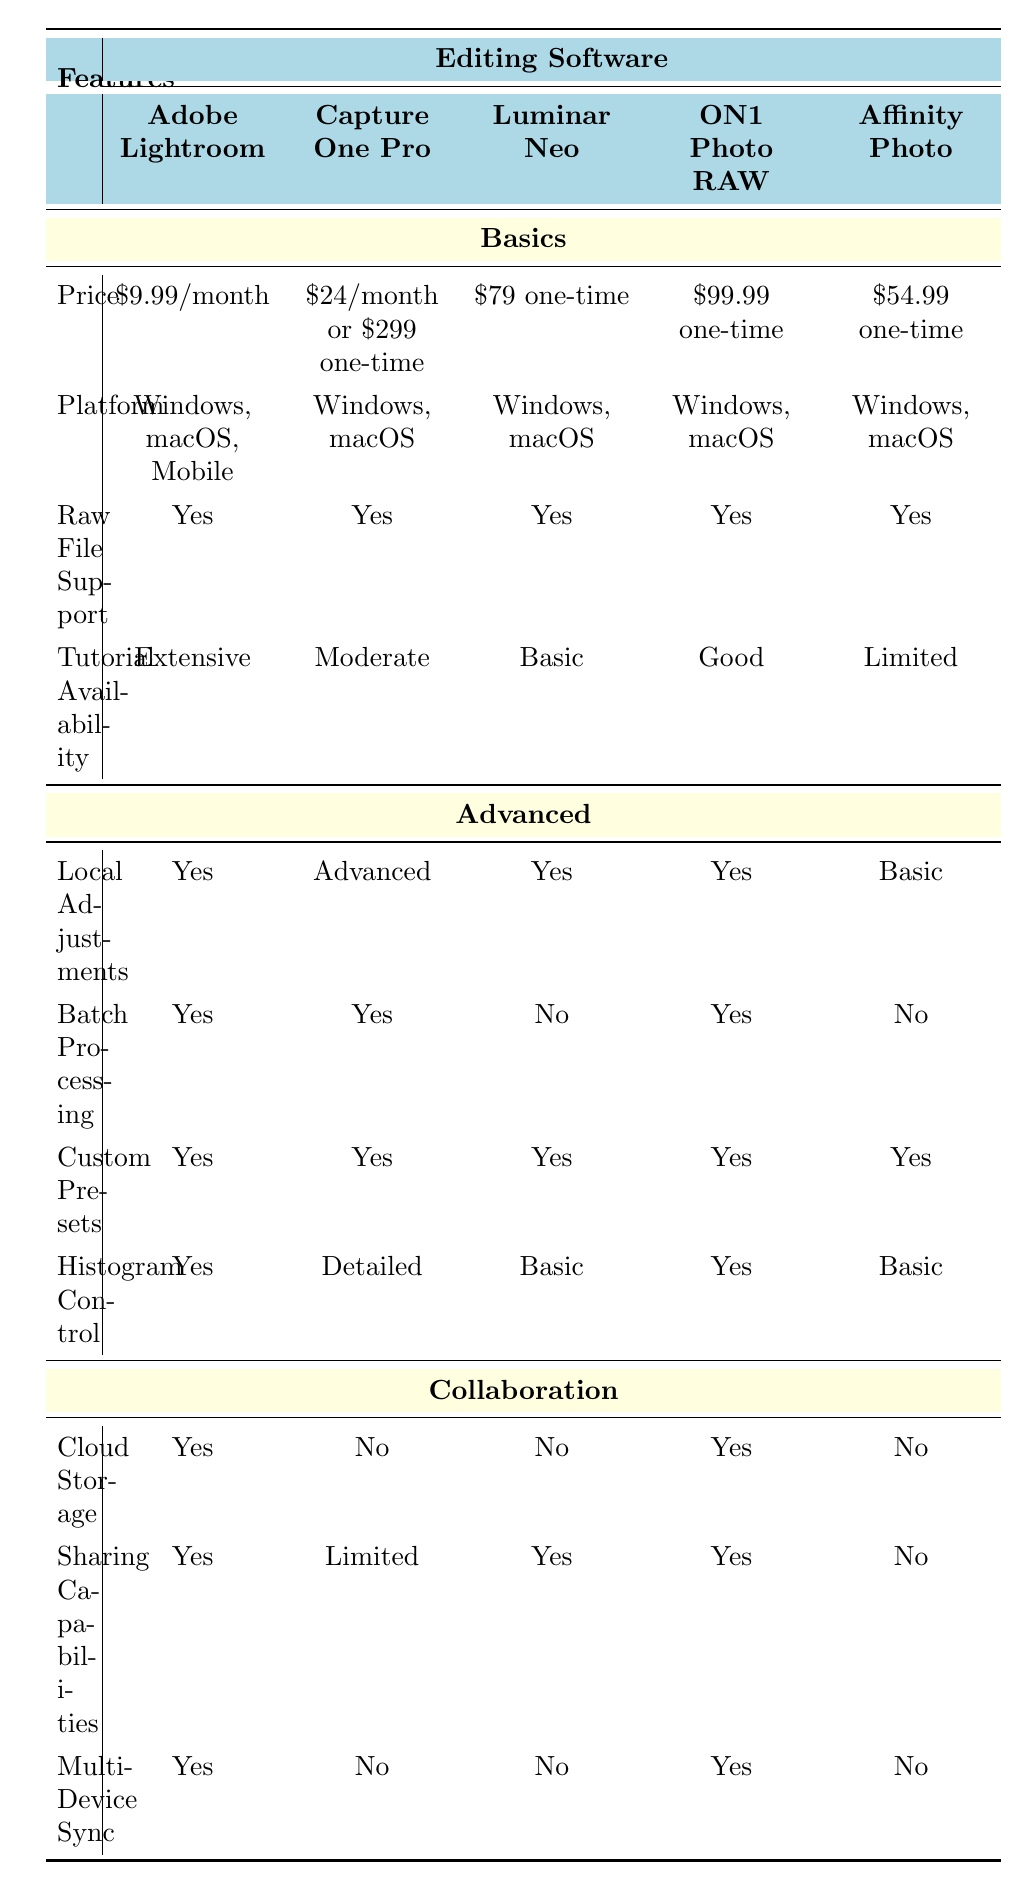What is the price of Adobe Lightroom? The table lists the price of Adobe Lightroom under the "Basics" section. It shows that the price is $9.99 per month.
Answer: $9.99/month Which software offers advanced local adjustments? The table indicates that both Capture One Pro and ON1 Photo RAW offer advanced local adjustments under the "Advanced" section.
Answer: Capture One Pro, ON1 Photo RAW Does Luminar Neo support batch processing? Under the "Advanced" section, the table clearly states that Luminar Neo does not support batch processing by indicating "No" for this feature.
Answer: No Which editing software provides cloud storage but not multi-device sync? By examining the "Collaboration" section, it's evident that ON1 Photo RAW provides cloud storage (Yes) but does not support multi-device sync (No).
Answer: ON1 Photo RAW How many software options provide extensive tutorial availability? Looking at the "Tutorial Availability" row, only Adobe Lightroom has "Extensive" listed, making it the only software option with this availability.
Answer: 1 What features does Affinity Photo lack in collaboration compared to ON1 Photo RAW? The table shows that Affinity Photo lacks cloud storage (No), sharing capabilities (No), and multi-device sync (No), while ON1 Photo RAW has all three features as Yes. Therefore, Affinity Photo lacks all collaboration features compared to ON1 Photo RAW.
Answer: All collaboration features Which software has the highest one-time price for purchase? The "Price" row in the table indicates that Capture One Pro has a one-time price of $299, which is the highest among all listed software options.
Answer: Capture One Pro Is it true that all software listed support raw file formats? The "Raw File Support" section displays "Yes" under all software options, confirming that they all support raw file formats.
Answer: Yes What is the average price of the software that requires a one-time payment? The one-time prices from the relevant software are: Capture One Pro ($299), Luminar Neo ($79), ON1 Photo RAW ($99.99), and Affinity Photo ($54.99). Adding these gives us a total of $299 + $79 + $99.99 + $54.99 = $532.99. Dividing this by 4 gives an average price of $133.25.
Answer: $133.25 Which software has limited tutorial availability alongside limited sharing capabilities? From the "Tutorial Availability" row, Capture One Pro is marked with "Moderate," and from the "Collaboration" section, it has "Limited" for sharing capabilities, thus meeting both criteria.
Answer: Capture One Pro 